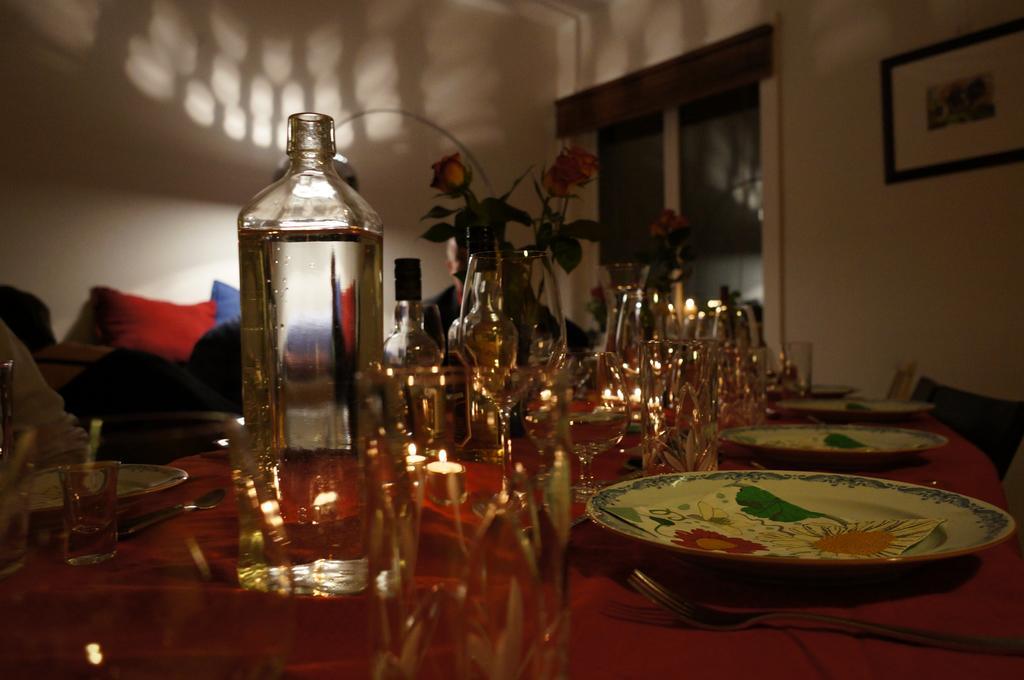In one or two sentences, can you explain what this image depicts? The picture is clicked inside a room. In the front of the image there is a table and on it there are candles, water bottles, alcohol bottles, glasses, plates, spoons and flower vases. There are people sitting at the table. Behind them there are cushions. There is a picture frame hanging on the wall. In the background there is wall and a glass window. 